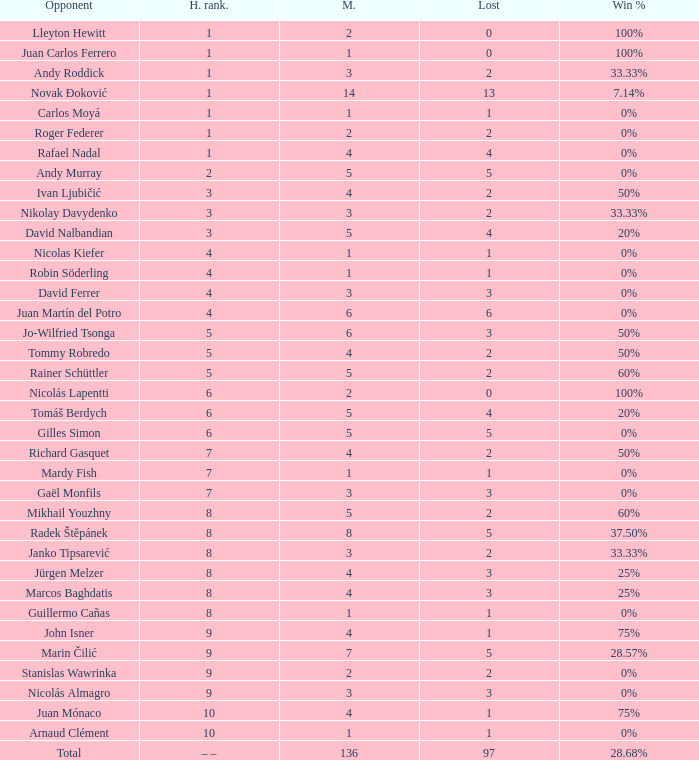What is the total number of Lost for the Highest Ranking of – –? 1.0. 